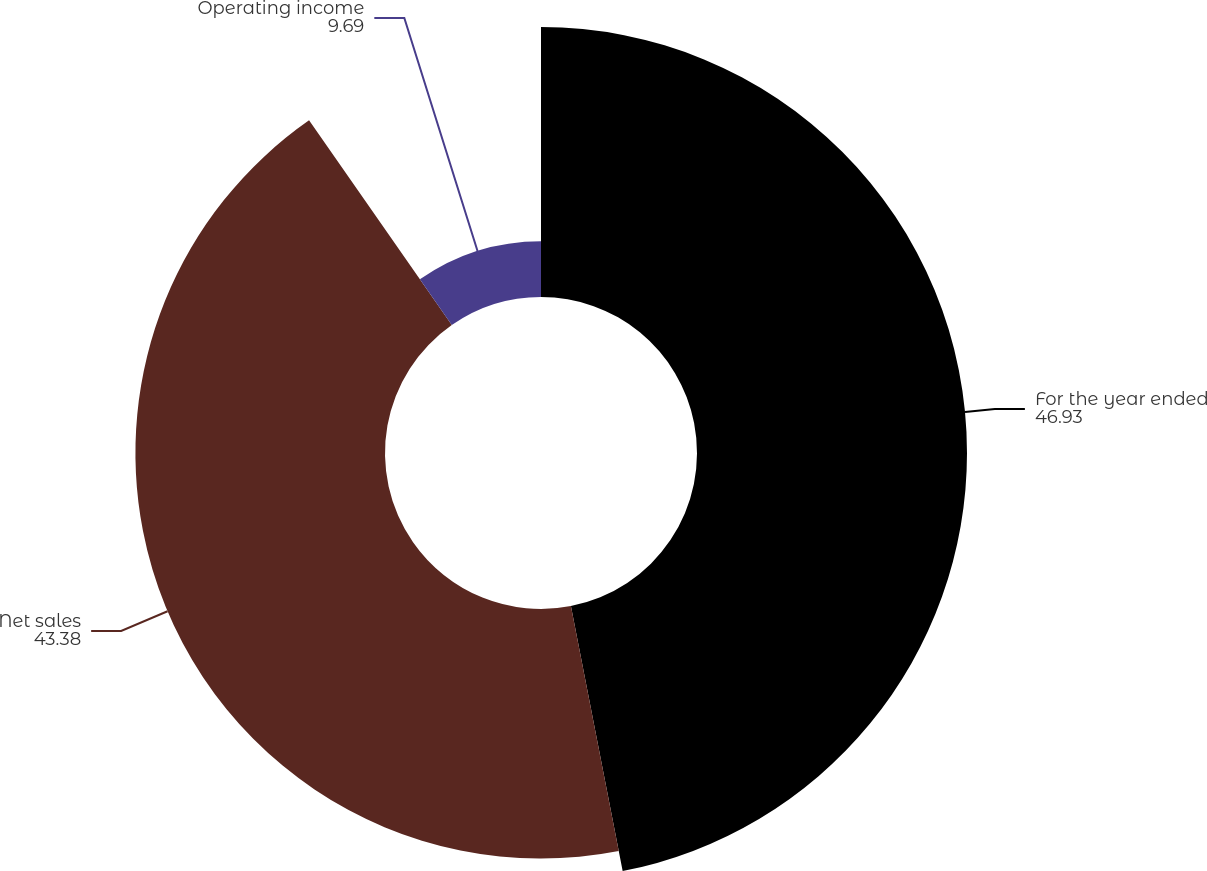Convert chart to OTSL. <chart><loc_0><loc_0><loc_500><loc_500><pie_chart><fcel>For the year ended<fcel>Net sales<fcel>Operating income<nl><fcel>46.93%<fcel>43.38%<fcel>9.69%<nl></chart> 